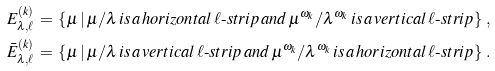Convert formula to latex. <formula><loc_0><loc_0><loc_500><loc_500>E _ { \lambda , \ell } ^ { ( k ) } \, & = \, \left \{ \mu \, | \, \mu / \lambda \, i s \, a \, h o r i z o n t a l \, \ell \text {-} s t r i p \, a n d \, \mu ^ { \omega _ { k } } / \lambda ^ { \omega _ { k } } \, i s \, a \, v e r t i c a l \, \ell \text {-} s t r i p \right \} \, , \\ \bar { E } _ { \lambda , \ell } ^ { ( k ) } \, & = \, \left \{ \mu \, | \, \mu / \lambda \, i s \, a \, v e r t i c a l \, \ell \text {-} s t r i p \, a n d \, \mu ^ { \omega _ { k } } / \lambda ^ { \omega _ { k } } \, i s \, a \, h o r i z o n t a l \, \ell \text {-} s t r i p \right \} \, .</formula> 